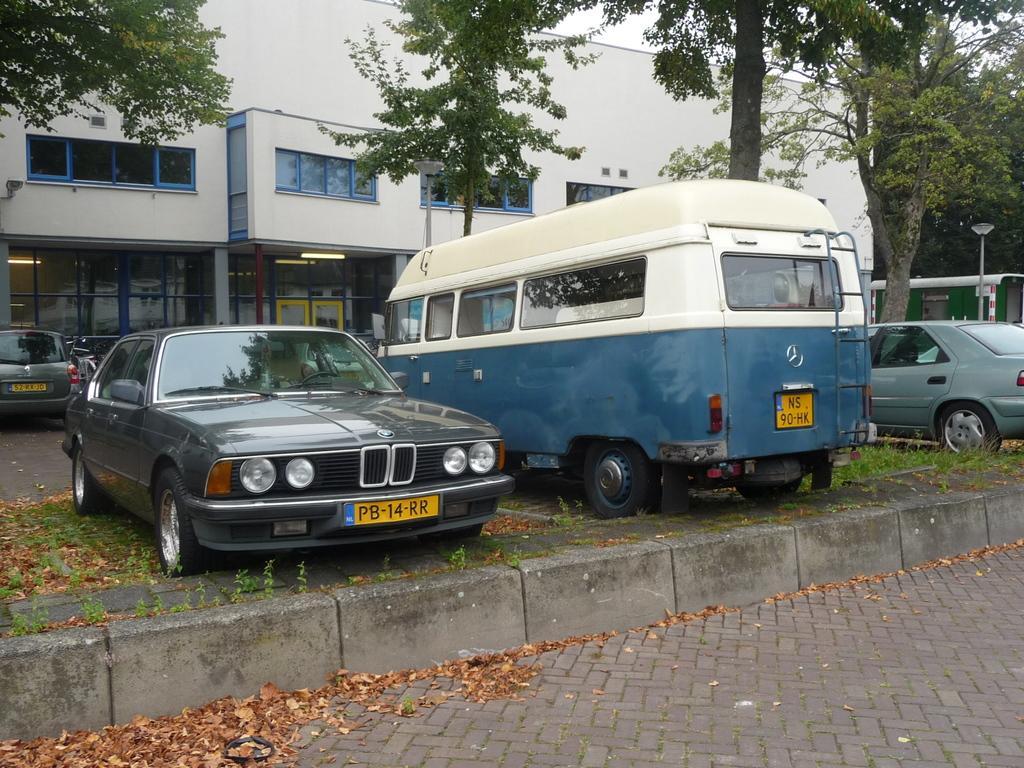Could you give a brief overview of what you see in this image? In this image there are vehicles parked on the ground. There are dried leaves and grass on the ground. Behind the vehicles there are buildings and trees. At the top there is the sky. To the right there is a street light pole. 